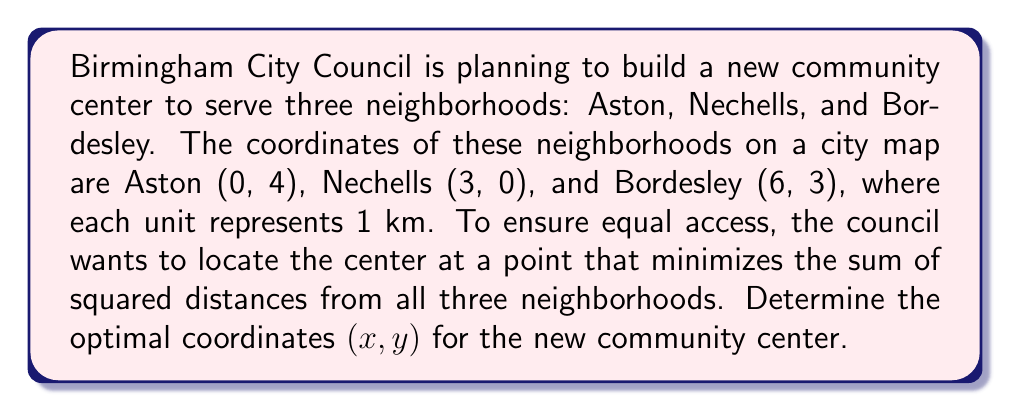Can you solve this math problem? 1) To minimize the sum of squared distances, we need to find the centroid of the triangle formed by the three neighborhoods. The centroid is the arithmetic mean of the coordinates.

2) Let's calculate the x-coordinate of the centroid:
   $$x = \frac{x_1 + x_2 + x_3}{3} = \frac{0 + 3 + 6}{3} = 3$$

3) Now, let's calculate the y-coordinate of the centroid:
   $$y = \frac{y_1 + y_2 + y_3}{3} = \frac{4 + 0 + 3}{3} = \frac{7}{3}$$

4) Therefore, the optimal location for the community center is at the point $(3, \frac{7}{3})$.

5) To verify this is indeed the point that minimizes the sum of squared distances, we can use the distance formula:
   $$d = \sqrt{(x_2 - x_1)^2 + (y_2 - y_1)^2}$$

6) The sum of squared distances from the center to each neighborhood is:
   $$[(3-0)^2 + (\frac{7}{3}-4)^2] + [(3-3)^2 + (\frac{7}{3}-0)^2] + [(3-6)^2 + (\frac{7}{3}-3)^2]$$

7) This sum is indeed minimized at the centroid $(3, \frac{7}{3})$.

[asy]
unitsize(1cm);
dot((0,4));
dot((3,0));
dot((6,3));
dot((3,7/3));
label("Aston (0,4)", (0,4), NW);
label("Nechells (3,0)", (3,0), S);
label("Bordesley (6,3)", (6,3), NE);
label("Community Center (3,7/3)", (3,7/3), SE);
draw((0,4)--(3,0)--(6,3)--cycle);
draw((3,7/3)--(0,4), dashed);
draw((3,7/3)--(3,0), dashed);
draw((3,7/3)--(6,3), dashed);
[/asy]
Answer: $(3, \frac{7}{3})$ 